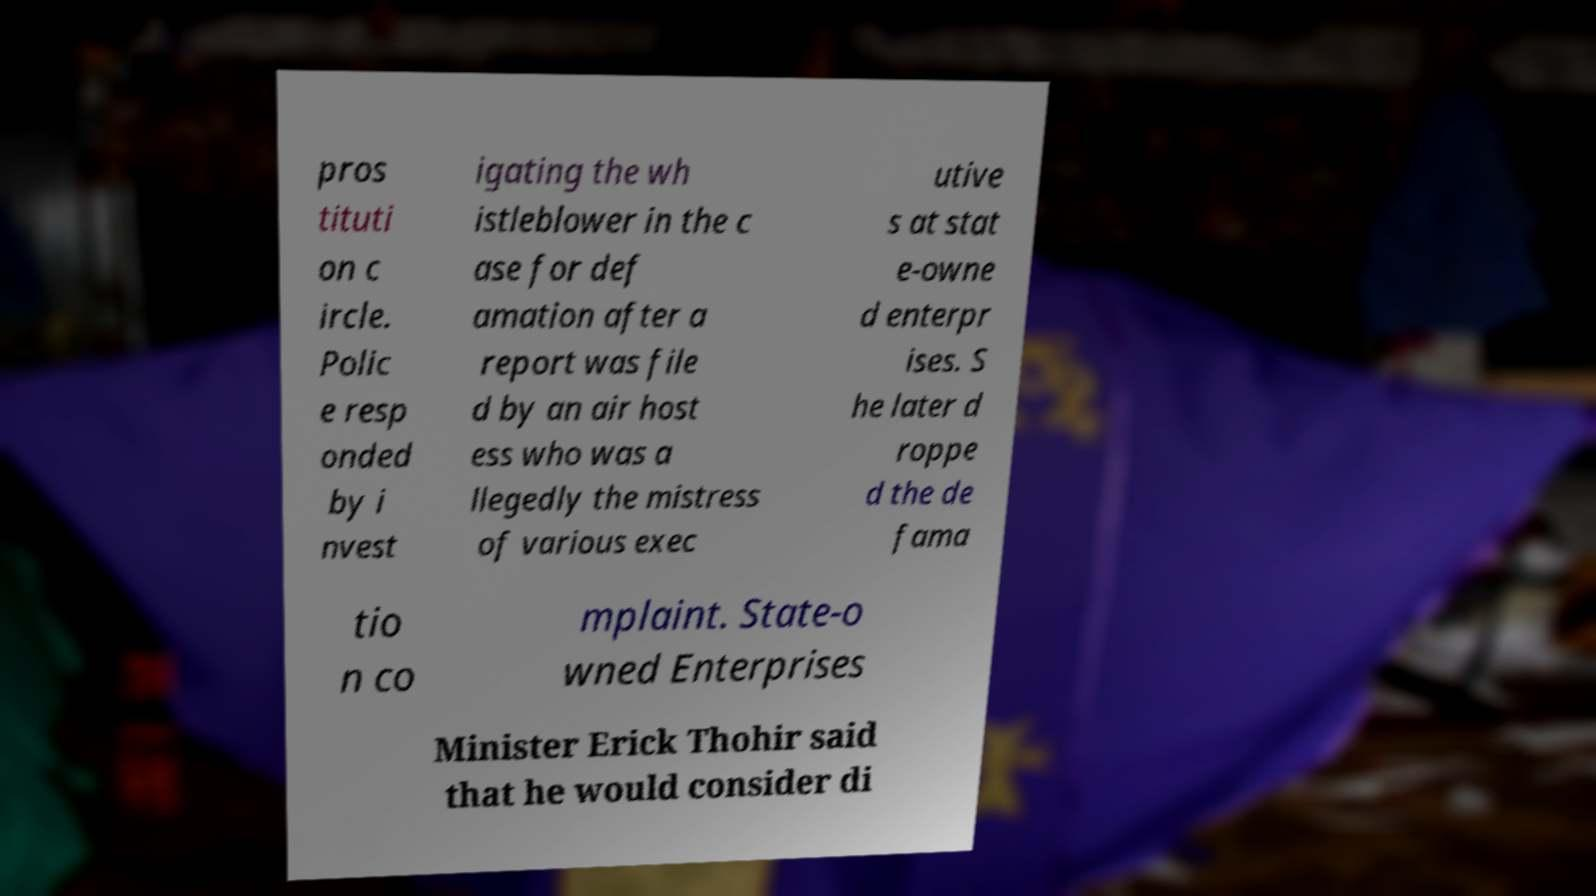What messages or text are displayed in this image? I need them in a readable, typed format. pros tituti on c ircle. Polic e resp onded by i nvest igating the wh istleblower in the c ase for def amation after a report was file d by an air host ess who was a llegedly the mistress of various exec utive s at stat e-owne d enterpr ises. S he later d roppe d the de fama tio n co mplaint. State-o wned Enterprises Minister Erick Thohir said that he would consider di 